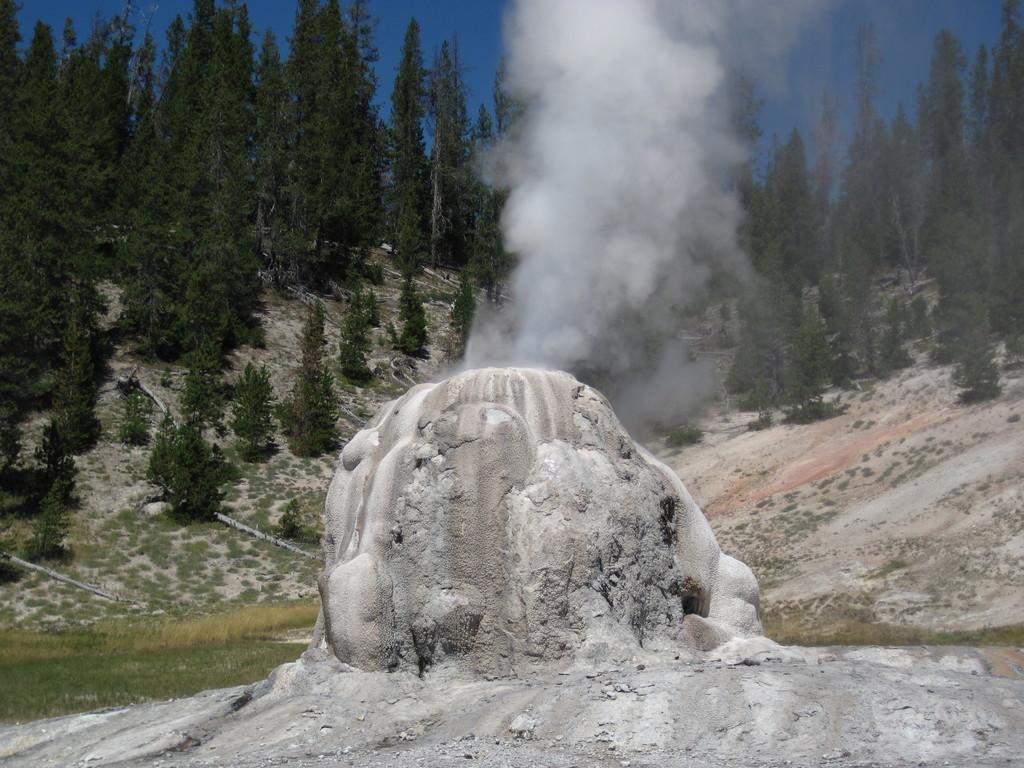Could you give a brief overview of what you see in this image? In this image I can see mountains, smoke, grass, trees and the sky. This image is taken near the mountains during a day. 